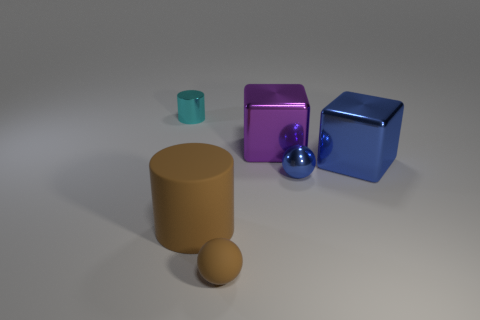Add 2 shiny cylinders. How many objects exist? 8 Add 6 cyan metal cylinders. How many cyan metal cylinders exist? 7 Subtract 0 red cylinders. How many objects are left? 6 Subtract all blocks. How many objects are left? 4 Subtract 1 cylinders. How many cylinders are left? 1 Subtract all yellow balls. Subtract all red cubes. How many balls are left? 2 Subtract all small cylinders. Subtract all tiny matte things. How many objects are left? 4 Add 3 small cyan metallic cylinders. How many small cyan metallic cylinders are left? 4 